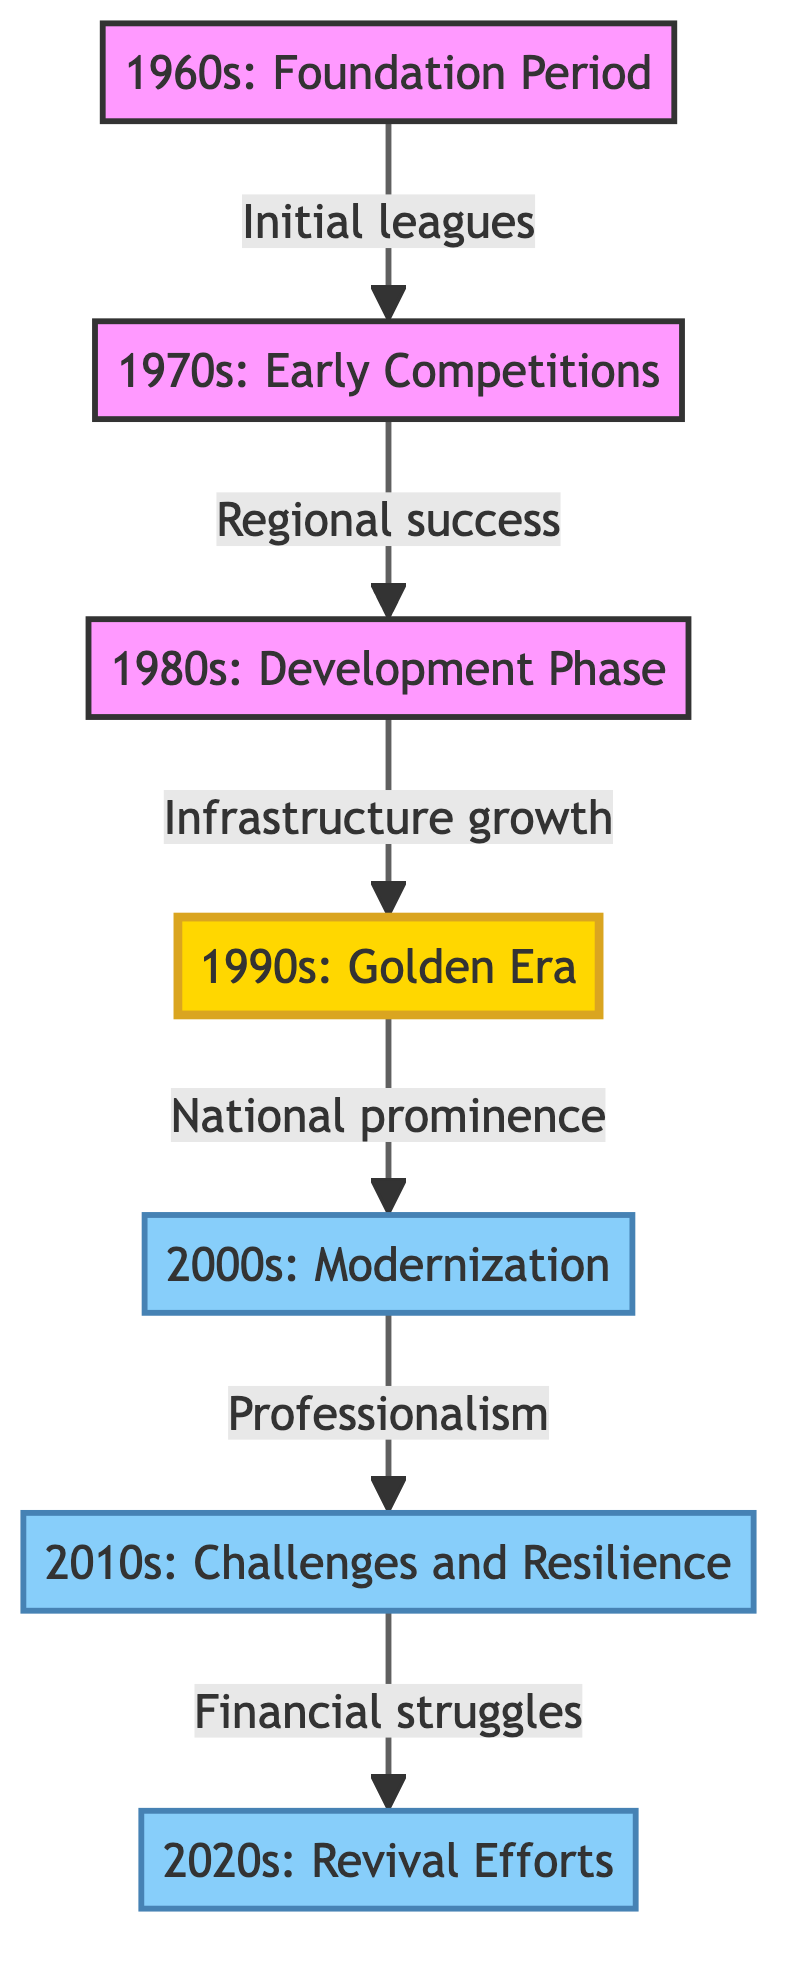What is the first decade represented in the flow chart? The first node in the diagram is labeled "1960s: Foundation Period," indicating that this was the initial phase of the football club's history.
Answer: 1960s: Foundation Period How many total decades are represented in the flow chart? The diagram contains seven nodes, each representing a distinct decade, hence there are seven decades in total.
Answer: 7 Which decade is associated with national prominence? The node labeled "1990s: Golden Era" specifies that this period saw the club rise to national prominence, reflecting its achievements during that time.
Answer: 1990s: Golden Era What significant change occurred in the 2000s? The flow from the node "1990s: Golden Era" to "2000s: Modernization" indicates that this period was marked by the introduction of modern training facilities and increased professionalism.
Answer: Modernization What was a major challenge faced in the 2010s? According to the connection from "2000s: Modernization" to "2010s: Challenges and Resilience," the club faced financial difficulties during this decade, which is highlighted as a significant challenge.
Answer: Financial difficulties Which decade signifies the revival efforts of the club? The final node "2020s: Revival Efforts" refers to renewed investments and a focus on youth development and community engagement, marking the club's revival period.
Answer: 2020s: Revival Efforts What trend connects the 1980s to the 1990s? The flow from "1980s: Development Phase" to "1990s: Golden Era" indicates that the development in the 1980s, including team infrastructure and fan engagement, led to a golden era of success in the following decade.
Answer: Development to Golden Era What structural change is highlighted in the 2000s? The node "2000s: Modernization" specifically mentions the introduction of modern training facilities, which signifies a structural and professional change for the club during this decade.
Answer: Modern training facilities 